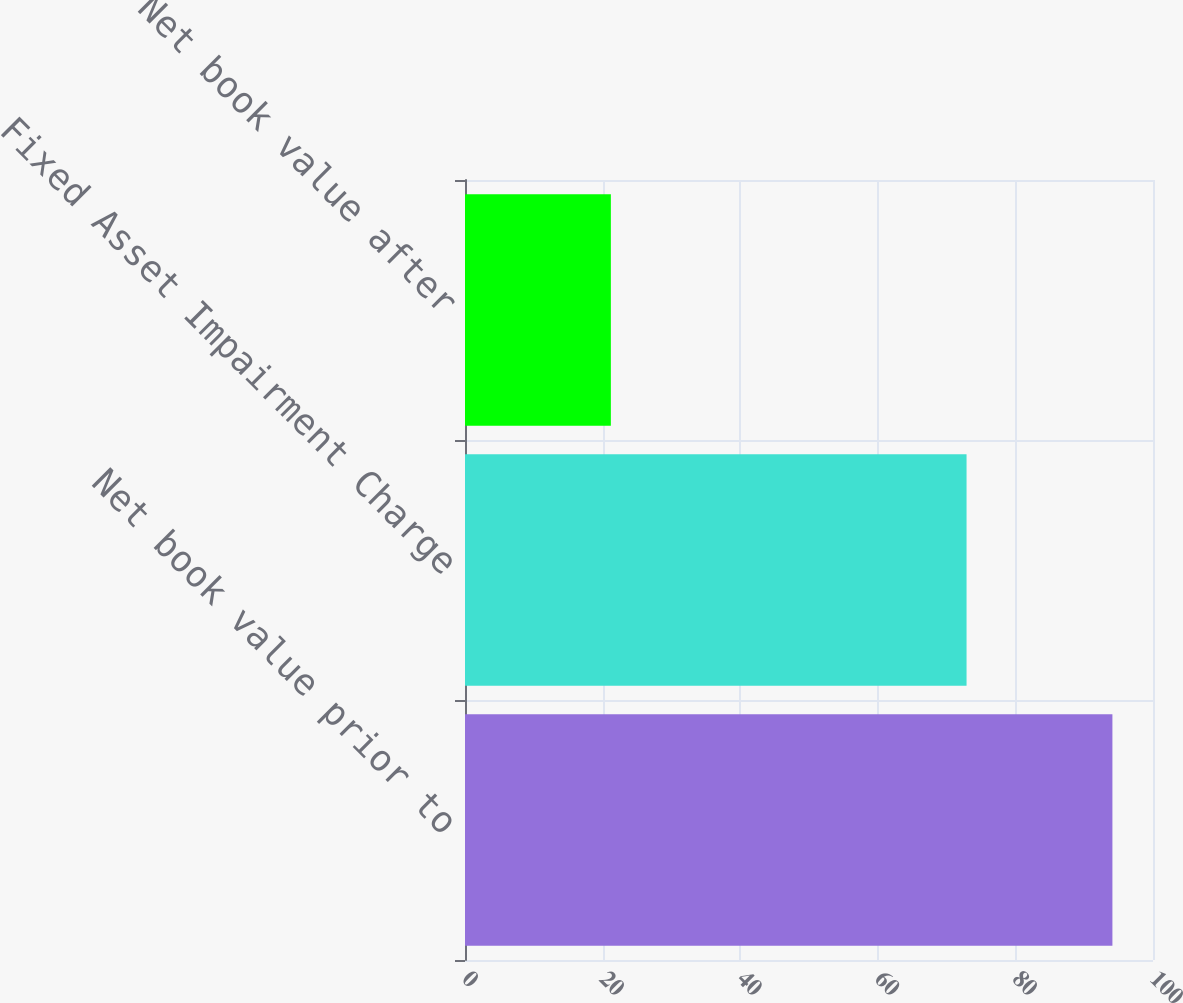Convert chart. <chart><loc_0><loc_0><loc_500><loc_500><bar_chart><fcel>Net book value prior to<fcel>Fixed Asset Impairment Charge<fcel>Net book value after<nl><fcel>94.1<fcel>72.9<fcel>21.2<nl></chart> 